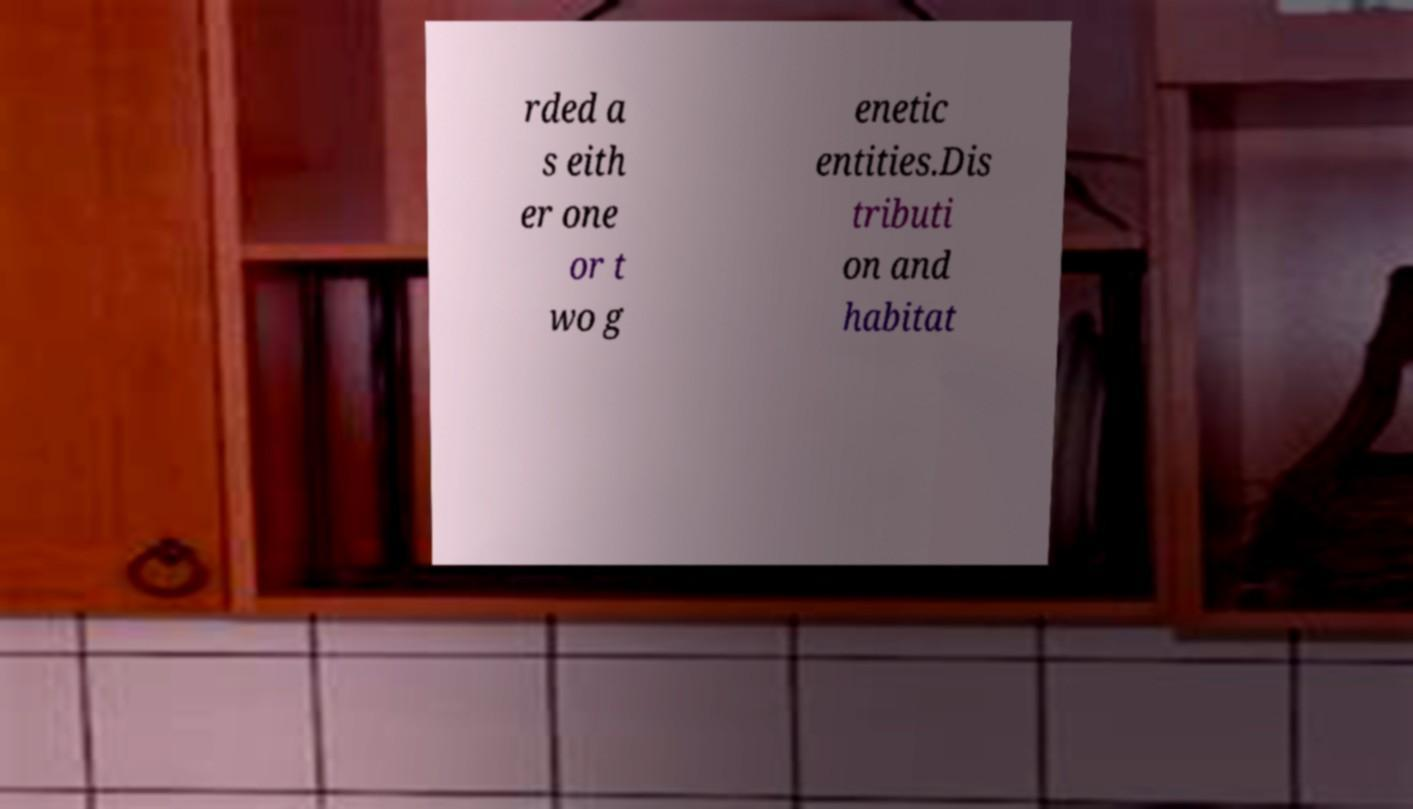Could you assist in decoding the text presented in this image and type it out clearly? rded a s eith er one or t wo g enetic entities.Dis tributi on and habitat 